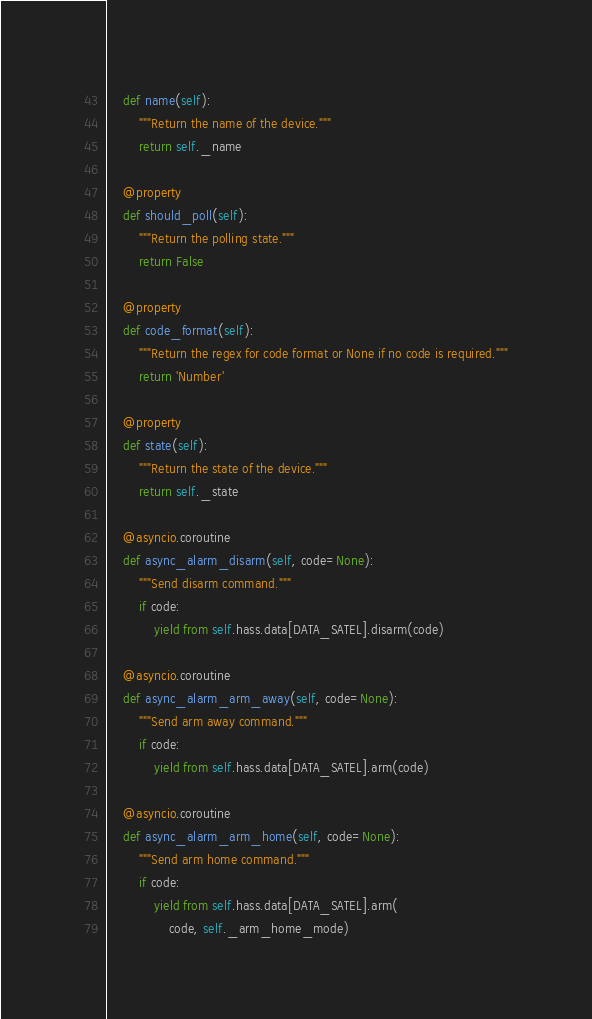Convert code to text. <code><loc_0><loc_0><loc_500><loc_500><_Python_>    def name(self):
        """Return the name of the device."""
        return self._name

    @property
    def should_poll(self):
        """Return the polling state."""
        return False

    @property
    def code_format(self):
        """Return the regex for code format or None if no code is required."""
        return 'Number'

    @property
    def state(self):
        """Return the state of the device."""
        return self._state

    @asyncio.coroutine
    def async_alarm_disarm(self, code=None):
        """Send disarm command."""
        if code:
            yield from self.hass.data[DATA_SATEL].disarm(code)

    @asyncio.coroutine
    def async_alarm_arm_away(self, code=None):
        """Send arm away command."""
        if code:
            yield from self.hass.data[DATA_SATEL].arm(code)

    @asyncio.coroutine
    def async_alarm_arm_home(self, code=None):
        """Send arm home command."""
        if code:
            yield from self.hass.data[DATA_SATEL].arm(
                code, self._arm_home_mode)</code> 